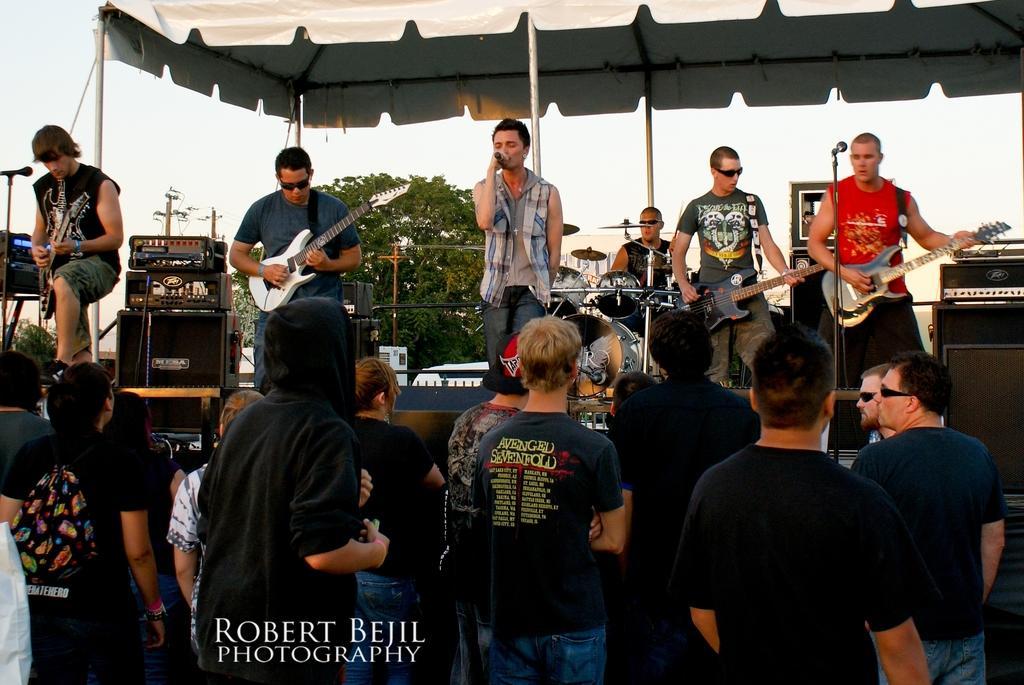Describe this image in one or two sentences. Here there are five men on the stage. one is singing a song by holding a mic in his hand. The other four members are playing guitar. The other man at the back is playing drums. And all the others are standing and watching their performance. There is a tent on the top. Behind them there is a tree. And we can also see an electrical pole. 